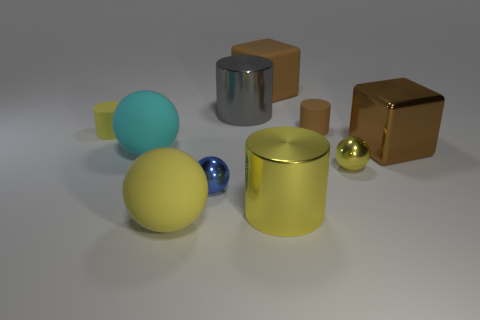Is the number of big rubber balls that are behind the large yellow metal cylinder greater than the number of yellow balls that are behind the small yellow shiny sphere?
Give a very brief answer. Yes. There is a yellow sphere right of the cylinder that is to the right of the metallic cylinder in front of the metal cube; how big is it?
Your answer should be very brief. Small. Are there any matte objects of the same color as the big rubber block?
Your answer should be compact. Yes. How many small purple matte things are there?
Your response must be concise. 0. What is the material of the tiny object that is behind the yellow matte object behind the cube that is in front of the tiny yellow cylinder?
Give a very brief answer. Rubber. Are there any other balls made of the same material as the blue ball?
Offer a terse response. Yes. Does the small brown object have the same material as the cyan object?
Give a very brief answer. Yes. What number of cubes are either small blue metal things or large rubber objects?
Your answer should be compact. 1. There is another small object that is made of the same material as the small brown thing; what is its color?
Provide a succinct answer. Yellow. Are there fewer tiny things than matte cylinders?
Provide a succinct answer. No. 